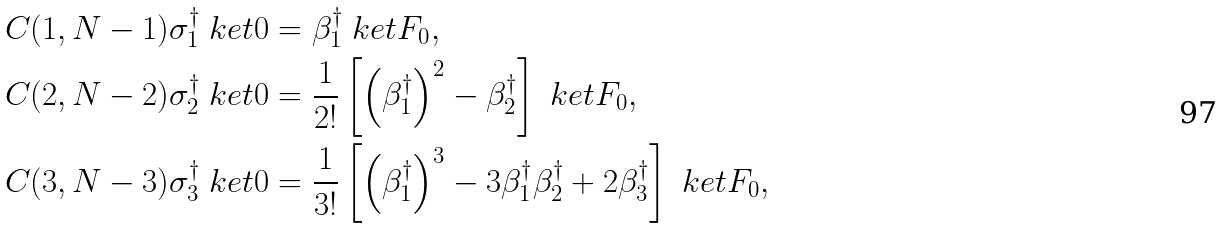Convert formula to latex. <formula><loc_0><loc_0><loc_500><loc_500>C ( 1 , N - 1 ) \sigma _ { 1 } ^ { \dagger } \ k e t { 0 } & = \beta _ { 1 } ^ { \dagger } \ k e t { F _ { 0 } } , \\ C ( 2 , N - 2 ) \sigma _ { 2 } ^ { \dagger } \ k e t { 0 } & = \frac { 1 } { 2 ! } \left [ \left ( \beta _ { 1 } ^ { \dagger } \right ) ^ { 2 } - \beta _ { 2 } ^ { \dagger } \right ] \ k e t { F _ { 0 } } , \\ C ( 3 , N - 3 ) \sigma _ { 3 } ^ { \dagger } \ k e t { 0 } & = \frac { 1 } { 3 ! } \left [ \left ( \beta _ { 1 } ^ { \dagger } \right ) ^ { 3 } - 3 \beta _ { 1 } ^ { \dagger } \beta _ { 2 } ^ { \dagger } + 2 \beta _ { 3 } ^ { \dagger } \right ] \ k e t { F _ { 0 } } ,</formula> 